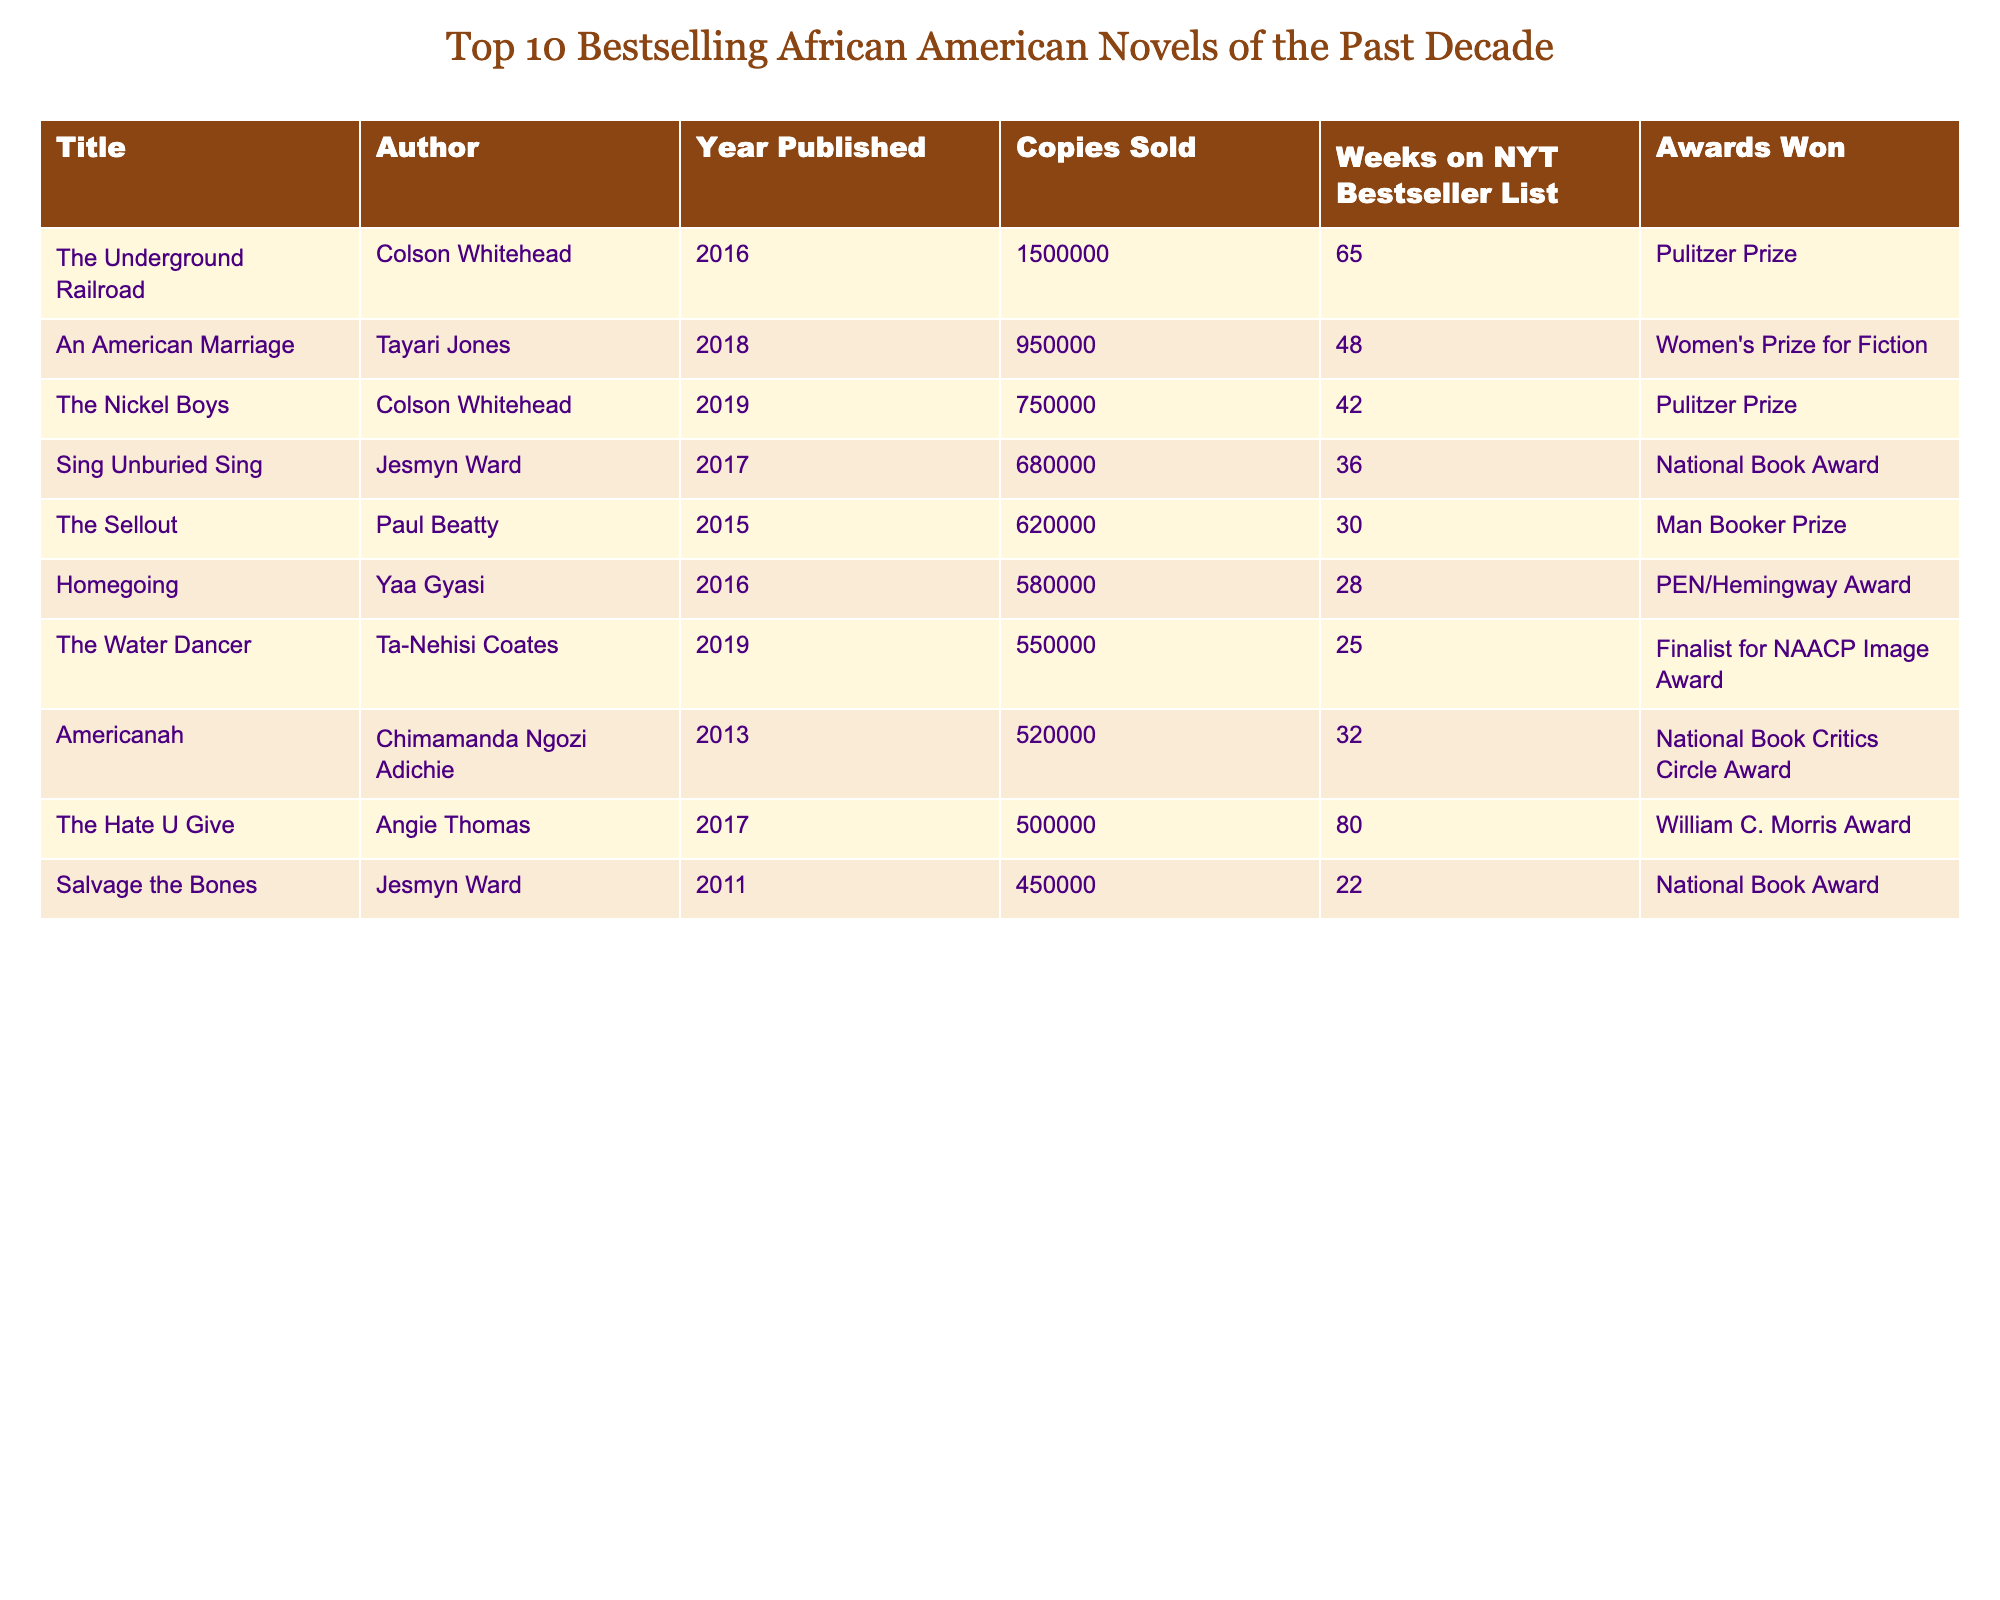What is the title of the bestselling African American novel from this list? The table shows "The Underground Railroad" by Colson Whitehead as the title with the highest sales of 1,500,000 copies.
Answer: The Underground Railroad Which author appears most frequently in this table? Colson Whitehead authored two bestselling novels: "The Underground Railroad" and "The Nickel Boys." Thus, he appears most frequently.
Answer: Colson Whitehead What is the total number of copies sold by the novels written by Jesmyn Ward? Jesmyn Ward wrote "Sing Unburied Sing" (680,000 copies) and "Salvage the Bones" (450,000 copies). Adding these gives 680,000 + 450,000 = 1,130,000 copies.
Answer: 1,130,000 How many weeks did "The Hate U Give" stay on the bestseller list? The table shows that "The Hate U Give" remained on the NYT Bestseller List for 80 weeks.
Answer: 80 weeks Which novel won a Pulitzer Prize? Both "The Underground Railroad" and "The Nickel Boys" won the Pulitzer Prize as indicated in the awards column.
Answer: The Underground Railroad and The Nickel Boys What is the average number of copies sold across all novels listed? The total copies sold is 4,155,000 (adding all copies), divided by 10 novels gives an average of 4,155,000 / 10 = 415,500.
Answer: 415,500 Is "An American Marriage" the only novel listed that won a Women's Prize for Fiction? Yes, according to the table, "An American Marriage" is the only novel with this specific award listed.
Answer: Yes Which novel has the least number of copies sold in this table? "Salvage the Bones" has the least sales with 450,000 copies sold.
Answer: Salvage the Bones How many awards did Yaa Gyasi's novel win? "Homegoing" by Yaa Gyasi won the PEN/Hemingway Award as noted in the awards column.
Answer: 1 award If you compare the number of copies sold for "The Nickel Boys" and "The Water Dancer," which is higher and by how much? "The Nickel Boys" sold 750,000 copies while "The Water Dancer" sold 550,000. The difference is 750,000 - 550,000 = 200,000 copies.
Answer: The Nickel Boys; 200,000 copies 